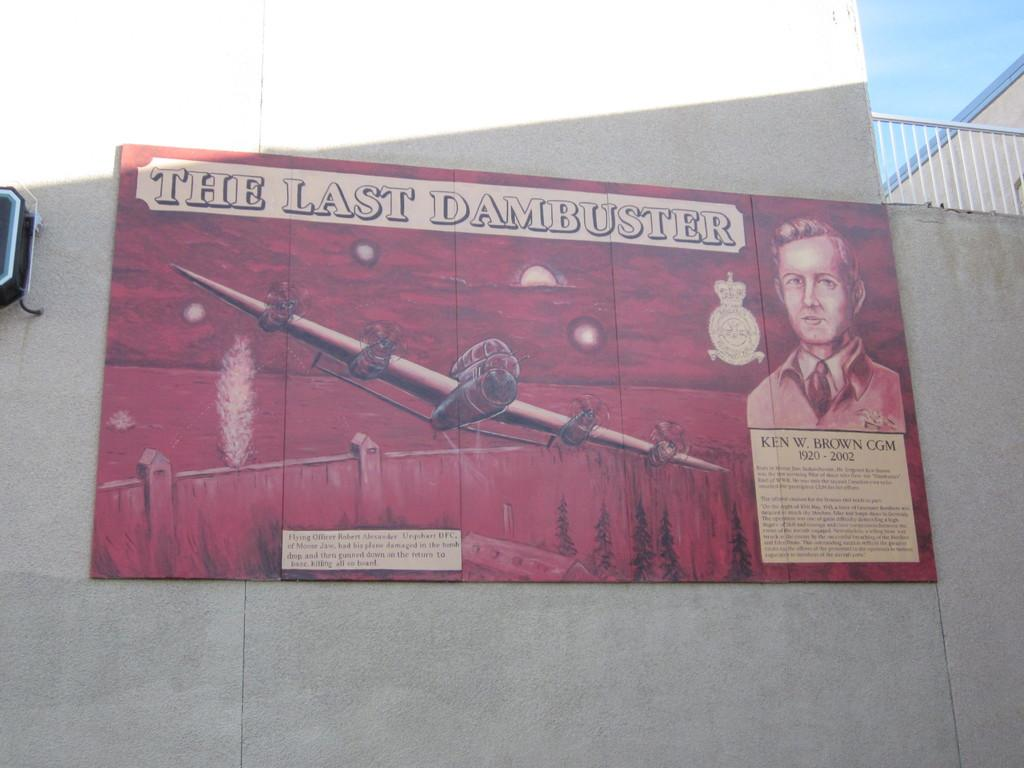<image>
Summarize the visual content of the image. A poster on a wall that says "The Last Dambuster" on it. 